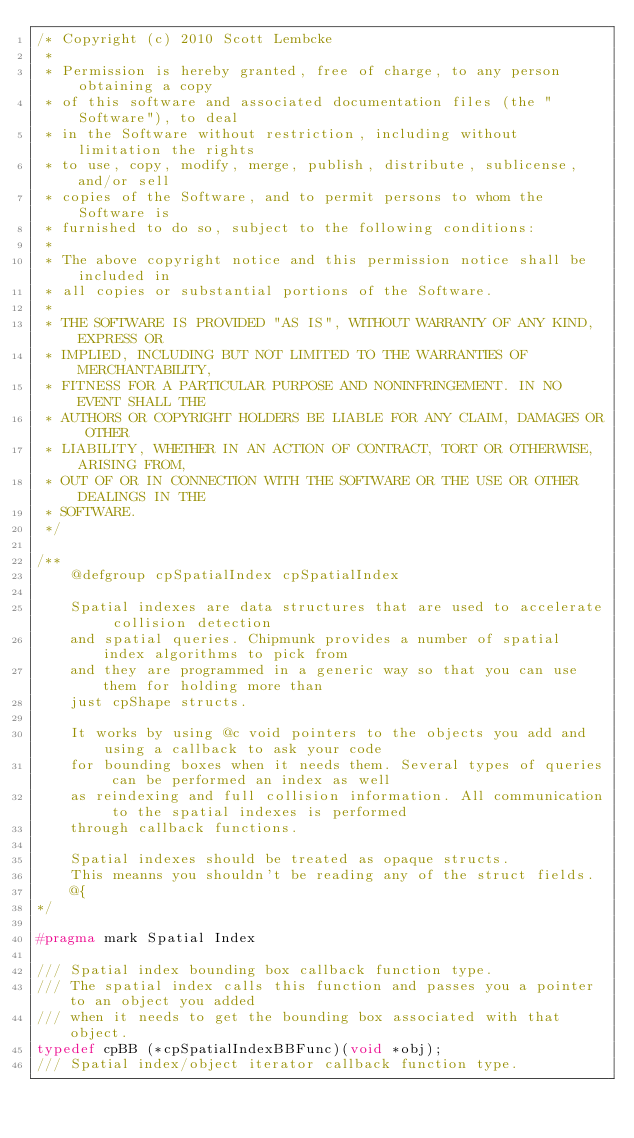Convert code to text. <code><loc_0><loc_0><loc_500><loc_500><_C_>/* Copyright (c) 2010 Scott Lembcke
 * 
 * Permission is hereby granted, free of charge, to any person obtaining a copy
 * of this software and associated documentation files (the "Software"), to deal
 * in the Software without restriction, including without limitation the rights
 * to use, copy, modify, merge, publish, distribute, sublicense, and/or sell
 * copies of the Software, and to permit persons to whom the Software is
 * furnished to do so, subject to the following conditions:
 * 
 * The above copyright notice and this permission notice shall be included in
 * all copies or substantial portions of the Software.
 * 
 * THE SOFTWARE IS PROVIDED "AS IS", WITHOUT WARRANTY OF ANY KIND, EXPRESS OR
 * IMPLIED, INCLUDING BUT NOT LIMITED TO THE WARRANTIES OF MERCHANTABILITY,
 * FITNESS FOR A PARTICULAR PURPOSE AND NONINFRINGEMENT. IN NO EVENT SHALL THE
 * AUTHORS OR COPYRIGHT HOLDERS BE LIABLE FOR ANY CLAIM, DAMAGES OR OTHER
 * LIABILITY, WHETHER IN AN ACTION OF CONTRACT, TORT OR OTHERWISE, ARISING FROM,
 * OUT OF OR IN CONNECTION WITH THE SOFTWARE OR THE USE OR OTHER DEALINGS IN THE
 * SOFTWARE.
 */

/**
	@defgroup cpSpatialIndex cpSpatialIndex
	
	Spatial indexes are data structures that are used to accelerate collision detection
	and spatial queries. Chipmunk provides a number of spatial index algorithms to pick from
	and they are programmed in a generic way so that you can use them for holding more than
	just cpShape structs.
	
	It works by using @c void pointers to the objects you add and using a callback to ask your code
	for bounding boxes when it needs them. Several types of queries can be performed an index as well
	as reindexing and full collision information. All communication to the spatial indexes is performed
	through callback functions.
	
	Spatial indexes should be treated as opaque structs.
	This meanns you shouldn't be reading any of the struct fields.
	@{
*/

#pragma mark Spatial Index

/// Spatial index bounding box callback function type.
/// The spatial index calls this function and passes you a pointer to an object you added
/// when it needs to get the bounding box associated with that object.
typedef cpBB (*cpSpatialIndexBBFunc)(void *obj);
/// Spatial index/object iterator callback function type.</code> 